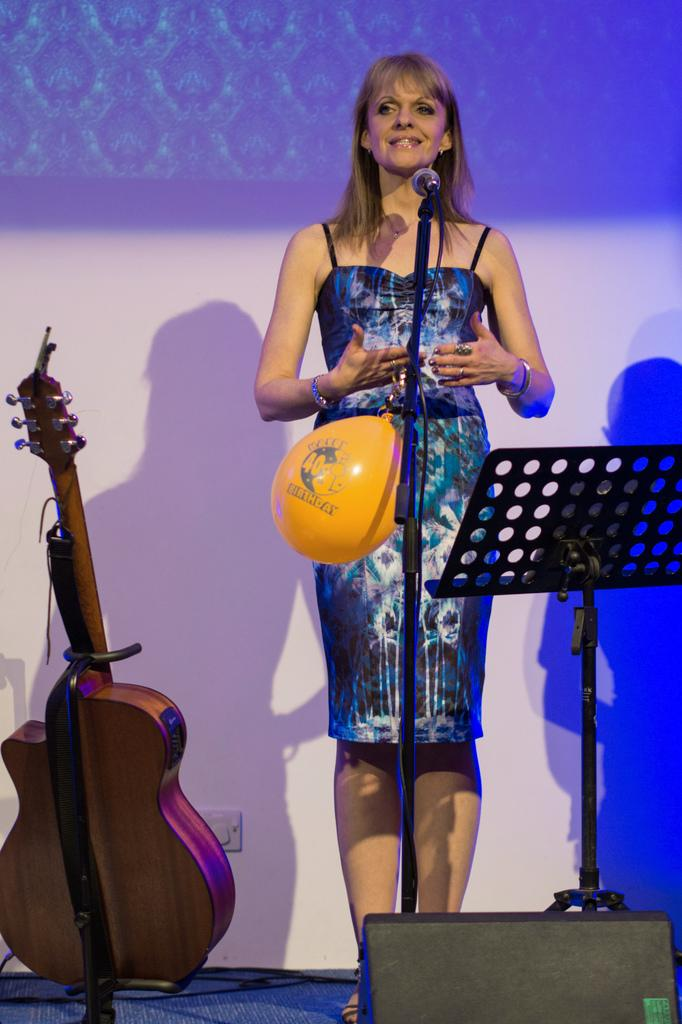Who is the main subject in the image? There is a woman in the image. What is the woman wearing? The woman is wearing a blue dress. What is the woman doing in the image? The woman is standing in front of a microphone. What other object can be seen in the image? There is a guitar in the image. What type of connection is the woman making with the basin in the image? There is no basin present in the image, so no connection can be made with it. 